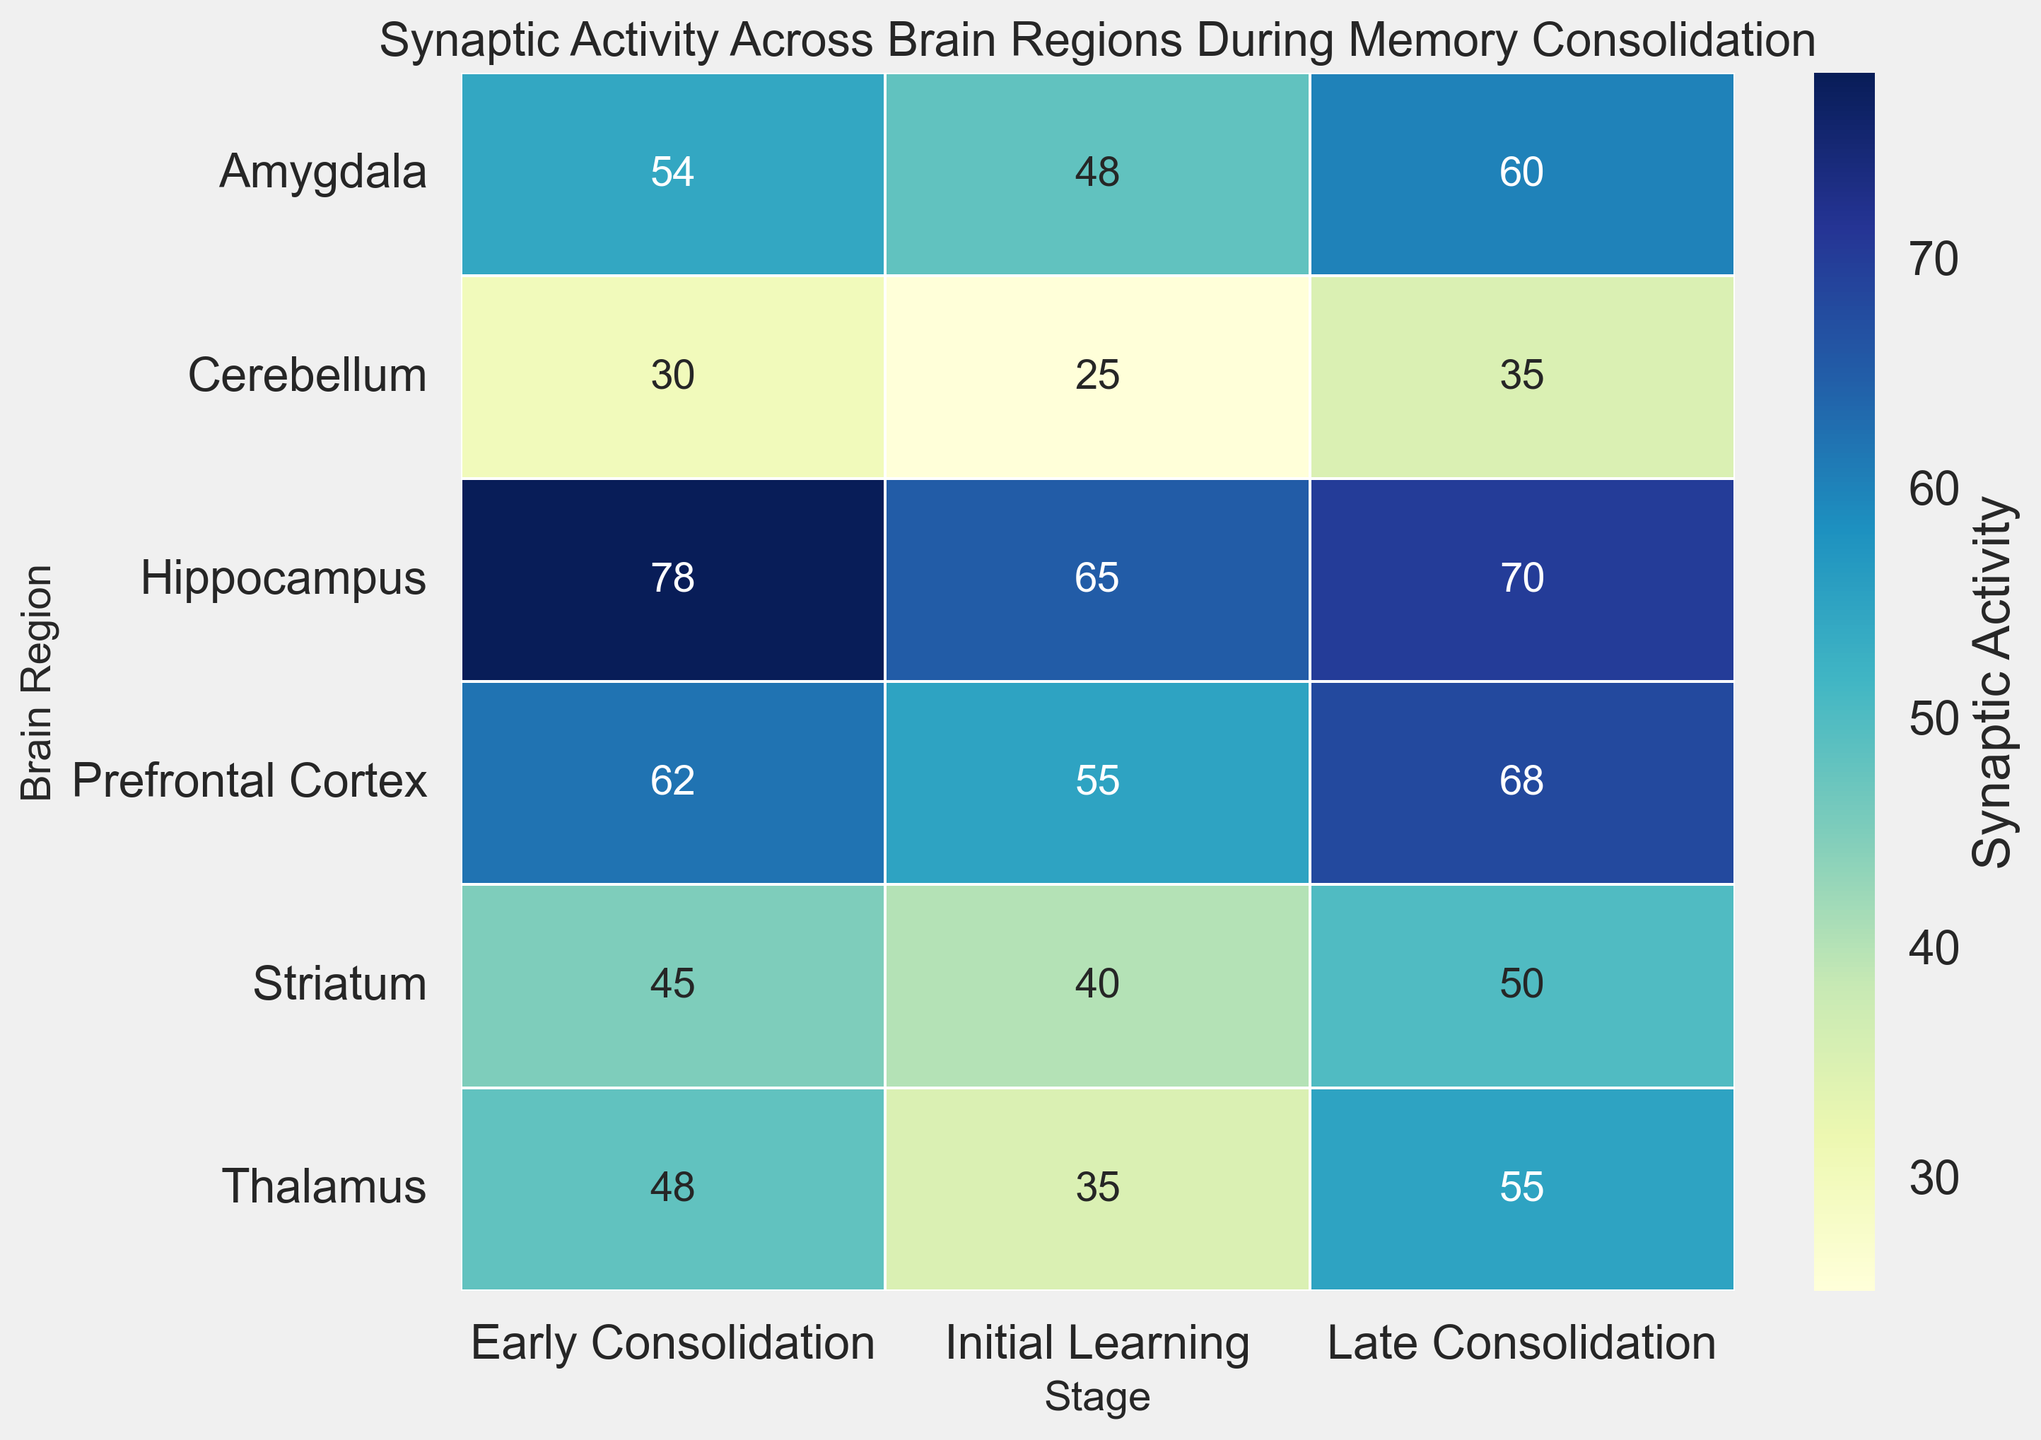What's the region with the highest synaptic activity during early consolidation? To determine the region with the highest synaptic activity during early consolidation, look at the column representing "Early Consolidation" and identify the maximum value. The highest value is 78, which corresponds to the Hippocampus.
Answer: Hippocampus Which brain regions show an increase in synaptic activity from initial learning to late consolidation? Observe the change in synaptic activity values from "Initial Learning" to "Late Consolidation" for each brain region. The regions with increasing values are Hippocampus (65 to 70), Prefrontal Cortex (55 to 68), Amygdala (48 to 60), Striatum (40 to 50), Thalamus (35 to 55), and Cerebellum (25 to 35).
Answer: Hippocampus, Prefrontal Cortex, Amygdala, Striatum, Thalamus, Cerebellum Compare the synaptic activity between the Hippocampus and the Cerebellum during early consolidation. Which one is higher and by how much? Find the synaptic activity values for Early Consolidation in both the Hippocampus and Cerebellum. Hippocampus has 78, and Cerebellum has 30. Subtract the Cerebellum value from the Hippocampus value to find the difference: 78 - 30 = 48.
Answer: Hippocampus by 48 What is the average synaptic activity in the prefrontal cortex across all stages of memory consolidation? Calculate the average by summing up the values for Prefrontal Cortex across all stages and dividing by the number of stages. The values are 55 (Initial Learning), 62 (Early Consolidation), and 68 (Late Consolidation). Sum these values: 55 + 62 + 68 = 185. Divide by the number of stages (3): 185 / 3 ≈ 61.67.
Answer: 61.67 Which brain region has the lowest synaptic activity during initial learning, and what is that value? Look at the "Initial Learning" column and identify the lowest value. The lowest value is 25, which corresponds to the Cerebellum.
Answer: Cerebellum (25) How does synaptic activity in the amygdala change from initial learning to late consolidation? Examine the synaptic activity values for the Amygdala during "Initial Learning," "Early Consolidation," and "Late Consolidation." The values are 48, 54, and 60, respectively, showing a gradual increase from 48 to 60.
Answer: Increases What is the range of synaptic activity in the striatum across all stages of memory consolidation? Find the minimum and maximum synaptic activity values for the Striatum across all stages. The values are 40 (Initial Learning), 45 (Early Consolidation), and 50 (Late Consolidation). The range is the difference between the maximum and minimum values: 50 - 40 = 10.
Answer: 10 Among the Thalamus and the Prefrontal Cortex during initial learning, which region has lower synaptic activity and by how much? Look at the "Initial Learning" values for Thalamus and Prefrontal Cortex. Thalamus is 35, and Prefrontal Cortex is 55. Subtract the Thalamus value from the Prefrontal Cortex value: 55 - 35 = 20.
Answer: Thalamus by 20 